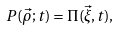Convert formula to latex. <formula><loc_0><loc_0><loc_500><loc_500>P ( \vec { \rho } ; t ) = \Pi ( \vec { \xi } , t ) ,</formula> 